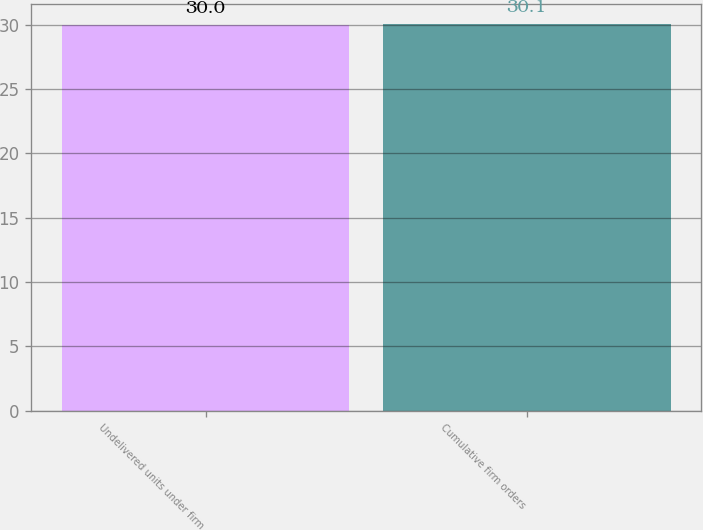Convert chart to OTSL. <chart><loc_0><loc_0><loc_500><loc_500><bar_chart><fcel>Undelivered units under firm<fcel>Cumulative firm orders<nl><fcel>30<fcel>30.1<nl></chart> 